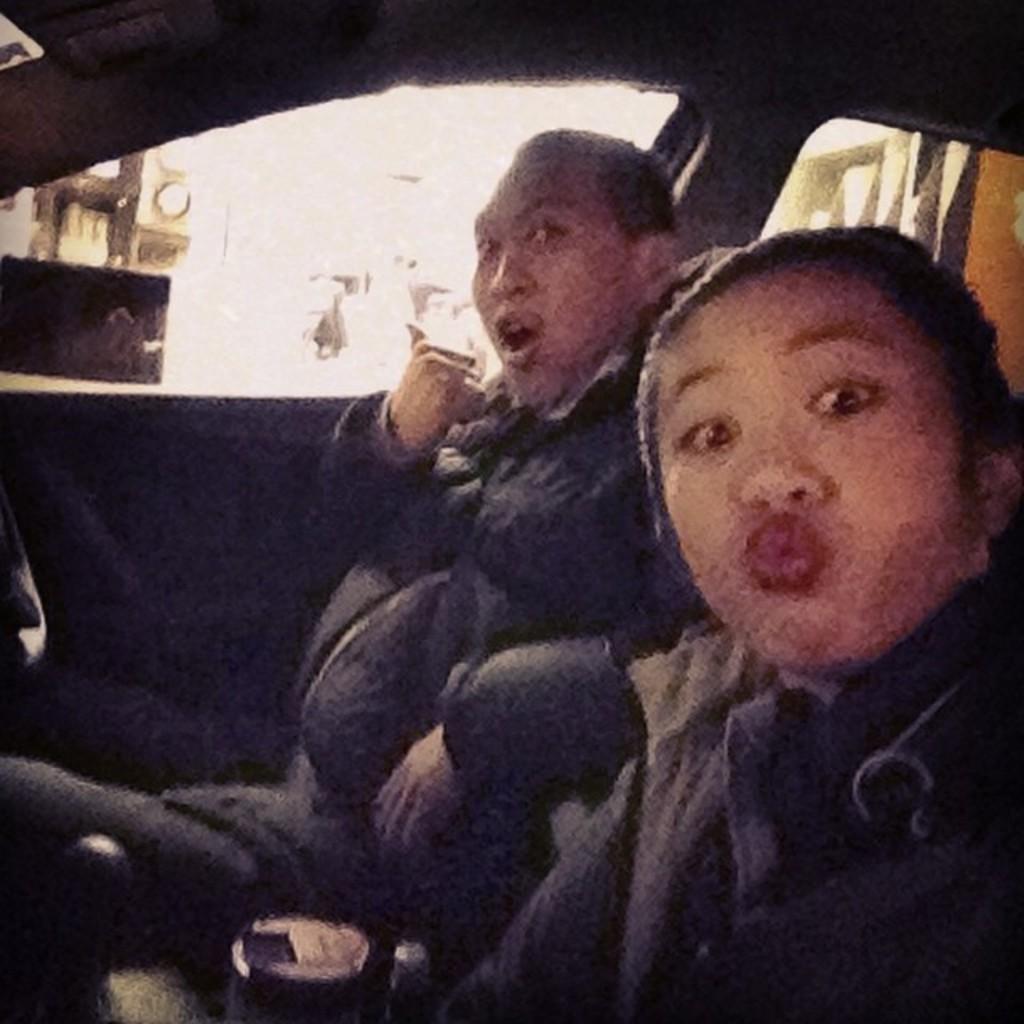How would you summarize this image in a sentence or two? This is the inner view of a vehicle. In this vehicle, there is a person and a woman sitting on the seats of the vehicle. This vehicle is having side doors, which are having glass windows and a roof. 